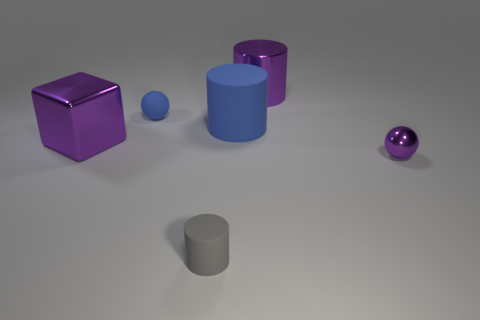How is the composition of objects arranged in terms of balance? The composition displays asymmetrical balance. Objects are scattered across the frame with varying sizes and distances from the viewer, creating a dynamic arrangement. The visual weight is distributed so that the scene feels balanced without being a mirror image on either side. 